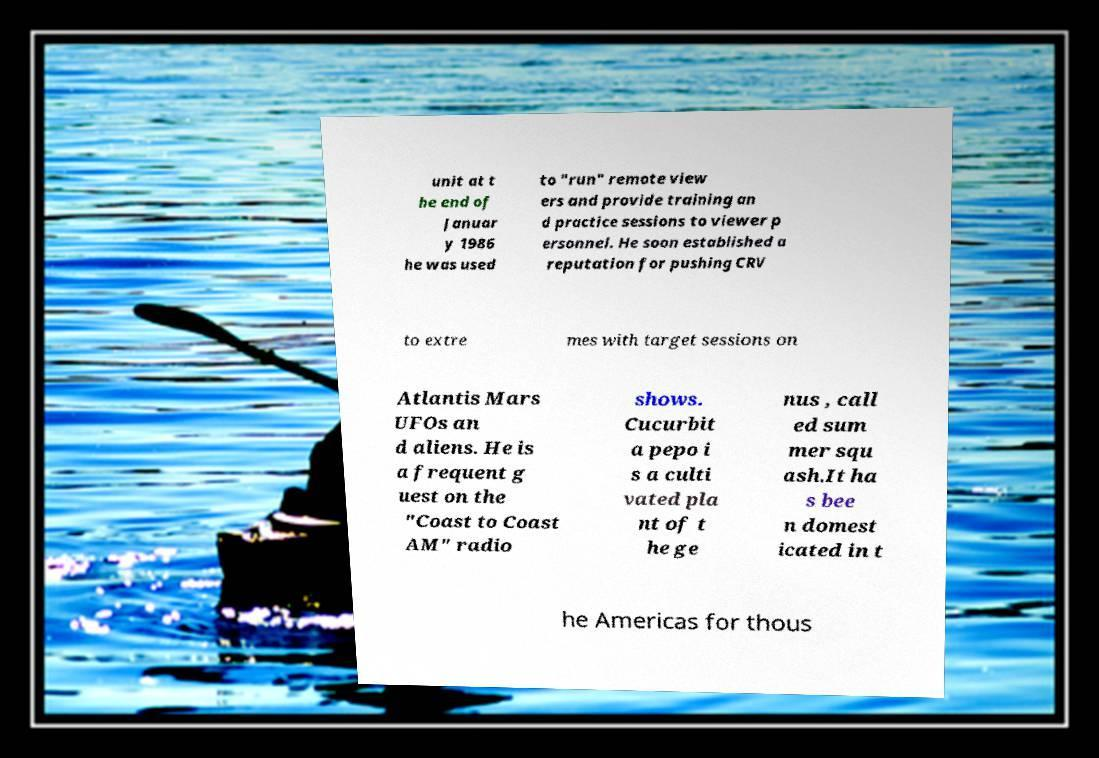Can you read and provide the text displayed in the image?This photo seems to have some interesting text. Can you extract and type it out for me? unit at t he end of Januar y 1986 he was used to "run" remote view ers and provide training an d practice sessions to viewer p ersonnel. He soon established a reputation for pushing CRV to extre mes with target sessions on Atlantis Mars UFOs an d aliens. He is a frequent g uest on the "Coast to Coast AM" radio shows. Cucurbit a pepo i s a culti vated pla nt of t he ge nus , call ed sum mer squ ash.It ha s bee n domest icated in t he Americas for thous 